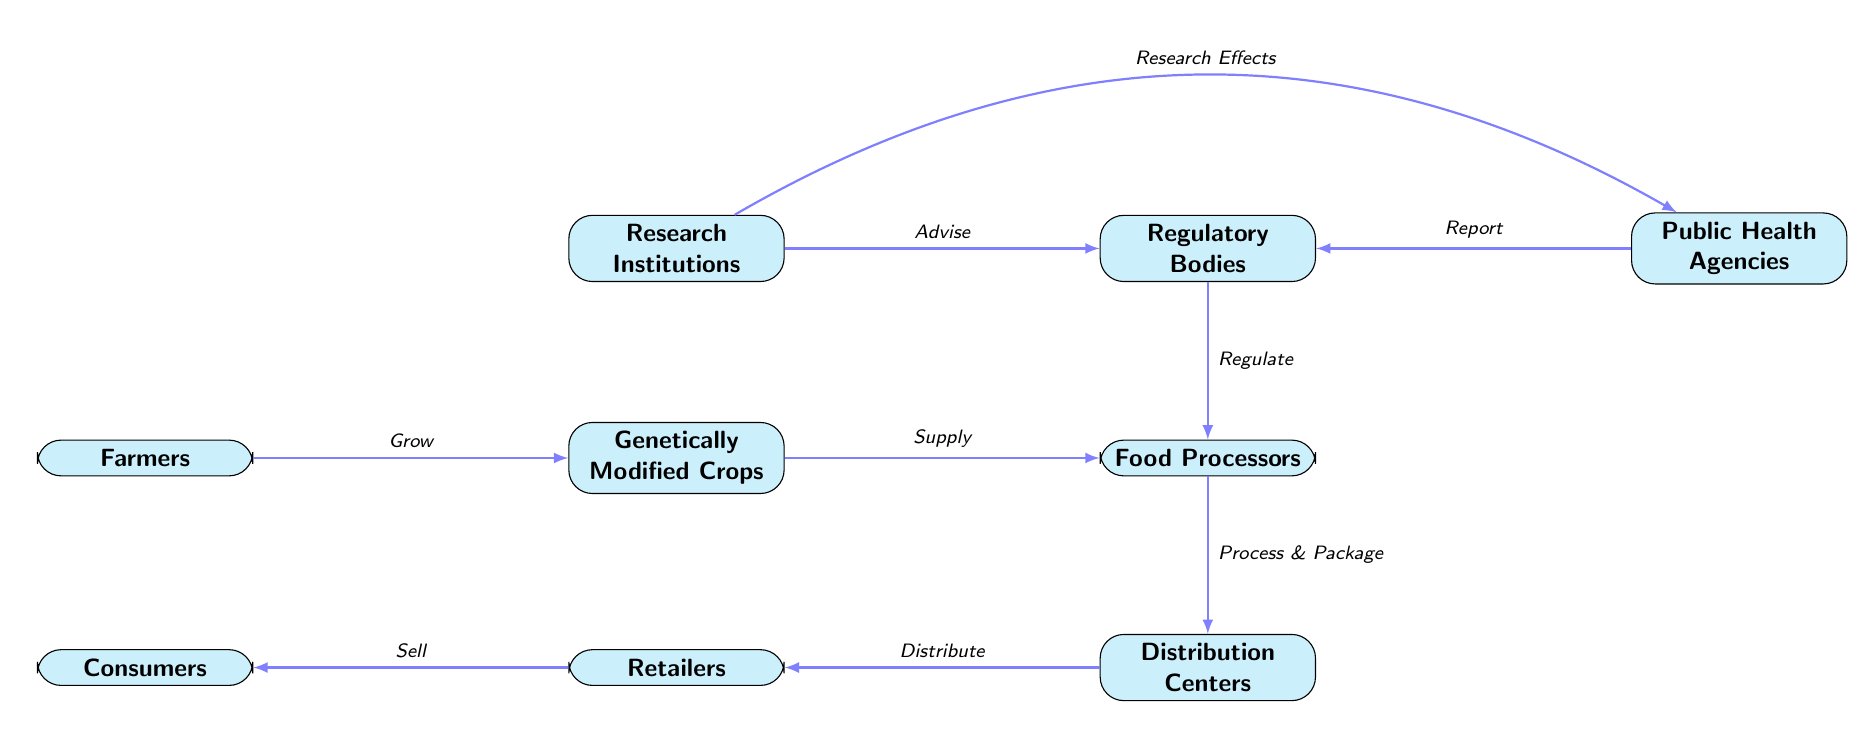What is the first node in the food chain? The first node is "Farmers," which is where the chain begins.
Answer: Farmers How many nodes are present in the diagram? There are a total of seven nodes: Farmers, Genetically Modified Crops, Food Processors, Distribution Centers, Retailers, Consumers, Regulatory Bodies, Research Institutions, and Public Health Agencies.
Answer: Nine Which node reports to the regulatory bodies? The "Public Health Agencies" node reports to "Regulatory Bodies," indicating their role in providing information regarding health concerns.
Answer: Public Health Agencies Who advises the regulatory bodies? "Research Institutions" advise the regulatory bodies, suggesting collaboration in assessing and regulating food safety related to genetically modified crops.
Answer: Research Institutions What action do food processors perform? Food processors "Process & Package" the genetically modified crops, transforming them into ready-to-consume products.
Answer: Process & Package What connects research institutions to public health agencies? Research institutions conduct studies on the effects of genetically modified crops and "Research Effects" to inform public health agencies.
Answer: Research Effects How do retailers interact with consumers? Retailers "Sell" the products to consumers, representing the final step in the food chain where consumers purchase food products.
Answer: Sell What is the function of the distribution centers? The distribution centers are responsible for the action "Distribute," which is essential for transporting food products from processors to retailers.
Answer: Distribute What governs the relationship between food processors and regulatory bodies? The regulatory bodies "Regulate" food processors, establishing the oversight required to ensure food safety in the processing of genetically modified crops.
Answer: Regulate 